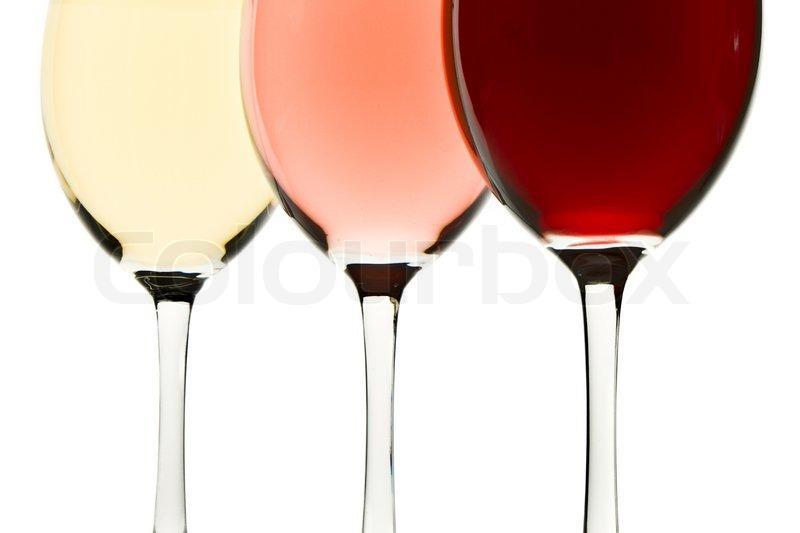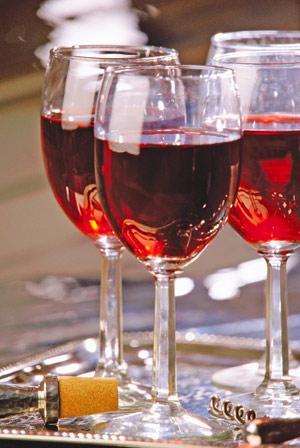The first image is the image on the left, the second image is the image on the right. Evaluate the accuracy of this statement regarding the images: "At least one glass of wine is active and swirling around the wine glass.". Is it true? Answer yes or no. No. The first image is the image on the left, the second image is the image on the right. Evaluate the accuracy of this statement regarding the images: "An image shows red wine splashing up the side of at least one stemmed glass.". Is it true? Answer yes or no. No. 